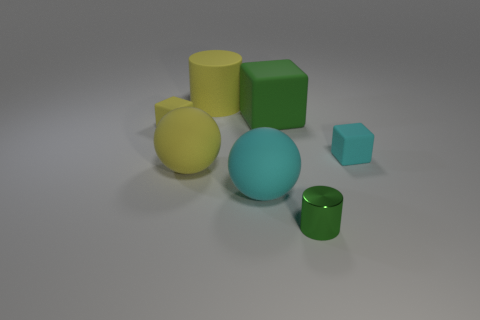Add 1 small matte objects. How many objects exist? 8 Subtract all cylinders. How many objects are left? 5 Add 6 tiny cyan rubber cylinders. How many tiny cyan rubber cylinders exist? 6 Subtract 0 brown spheres. How many objects are left? 7 Subtract all tiny green metallic objects. Subtract all yellow spheres. How many objects are left? 5 Add 5 yellow objects. How many yellow objects are left? 8 